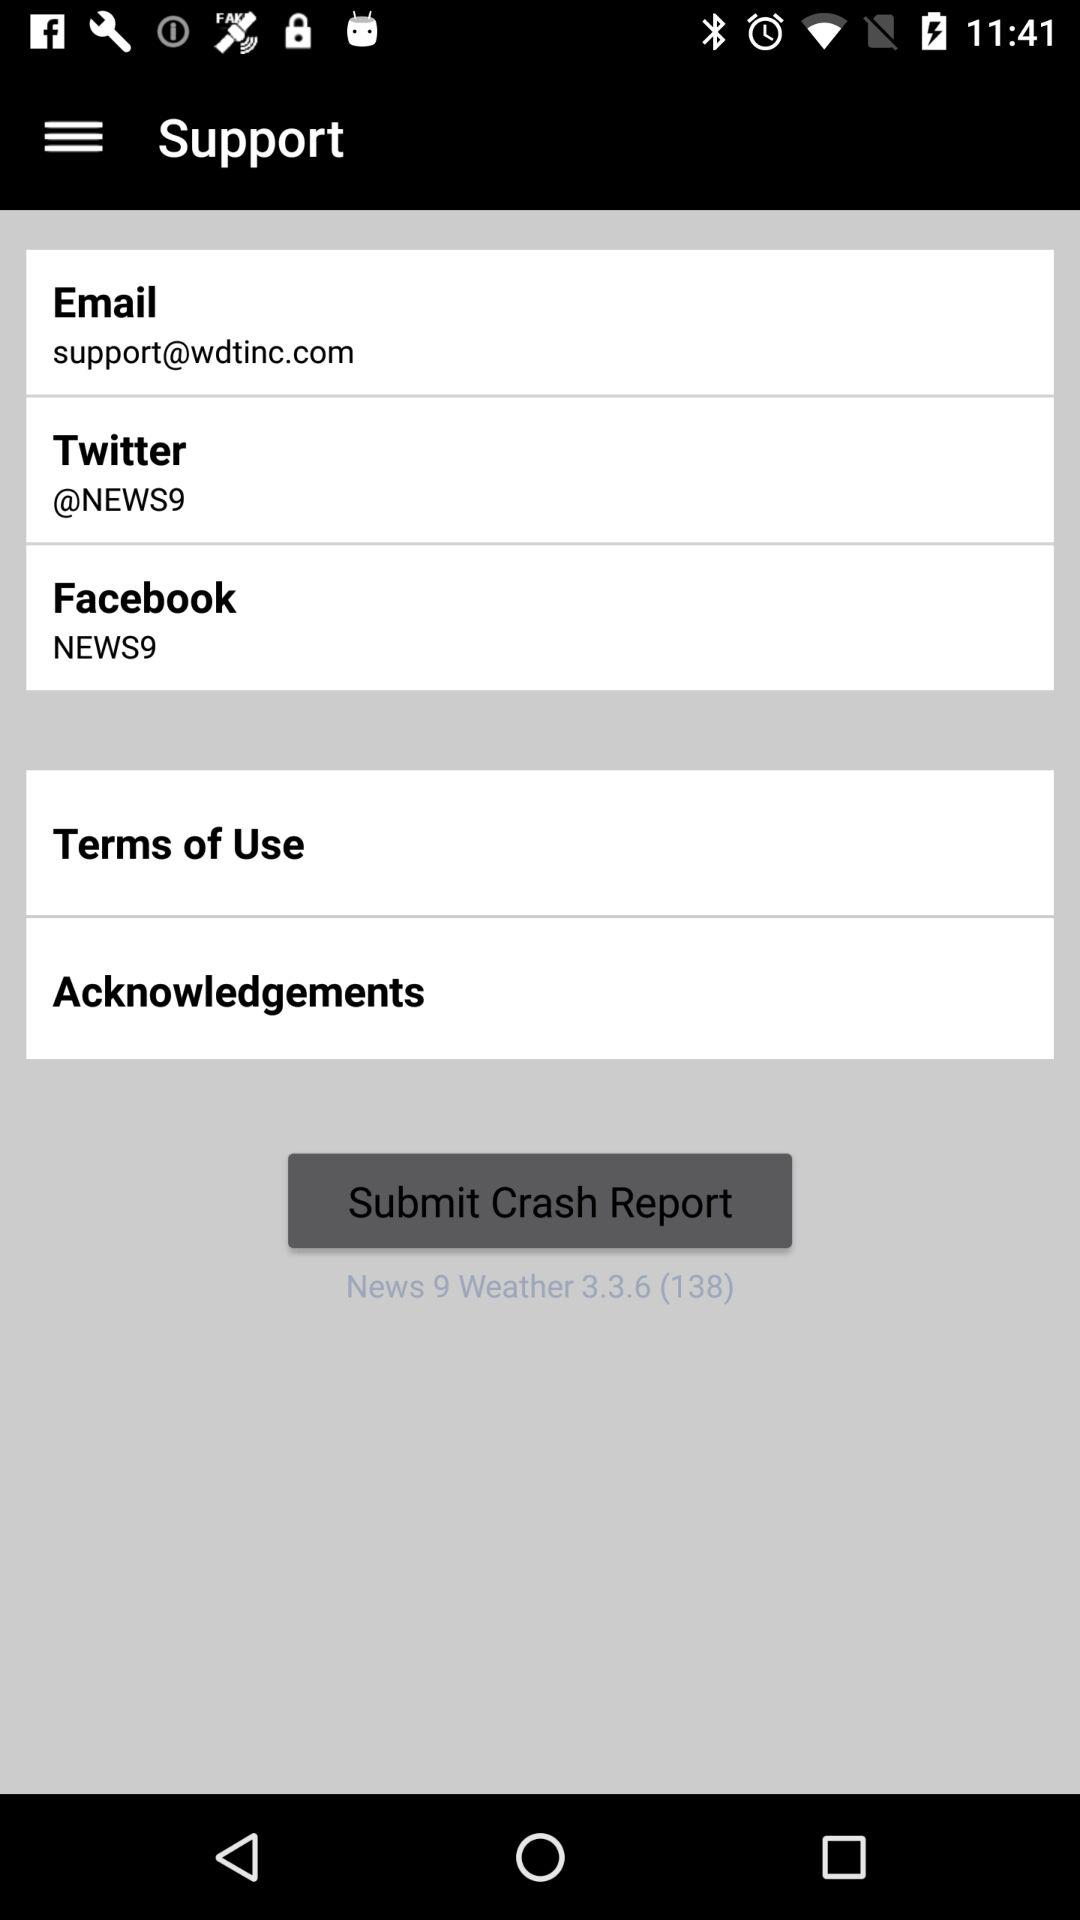What is the Facebook ID? The Facebook ID is NEWS9. 